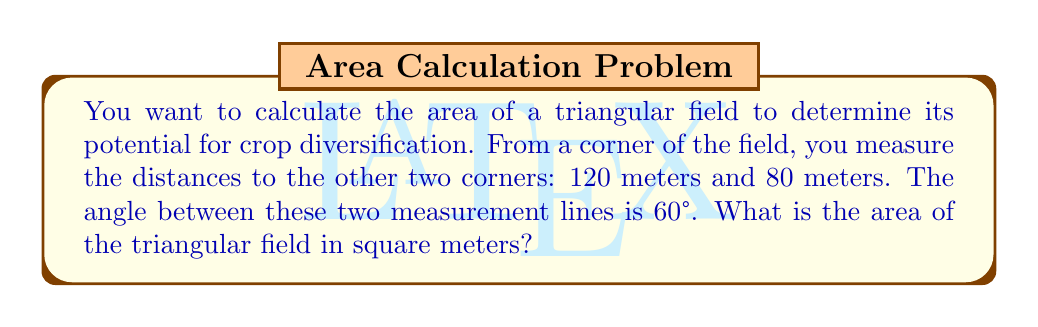Solve this math problem. Let's approach this step-by-step using trigonometry:

1) We have a triangle with two known sides (a = 120 m, b = 80 m) and the included angle (C = 60°). This is a perfect scenario for using the formula for the area of a triangle given two sides and the included angle:

   $$\text{Area} = \frac{1}{2}ab\sin(C)$$

2) Let's substitute our known values:

   $$\text{Area} = \frac{1}{2} \cdot 120 \cdot 80 \cdot \sin(60°)$$

3) Simplify:
   $$\text{Area} = 4800 \cdot \sin(60°)$$

4) We know that $\sin(60°) = \frac{\sqrt{3}}{2}$, so:

   $$\text{Area} = 4800 \cdot \frac{\sqrt{3}}{2}$$

5) Simplify:
   $$\text{Area} = 2400\sqrt{3}$$

6) If we want to calculate this as a decimal:
   $$\text{Area} \approx 4157.12 \text{ m}^2$$

[asy]
import geometry;

size(200);
pair A=(0,0), B=(120,0), C=(60,80*sqrt(3));
draw(A--B--C--cycle);
label("120 m",B/2,S);
label("80 m",(A+C)/2,NW);
label("60°",A,SE);
dot("A",A,SW);
dot("B",B,SE);
dot("C",C,N);
[/asy]
Answer: $2400\sqrt{3} \text{ m}^2$ or approximately 4157.12 $\text{m}^2$ 